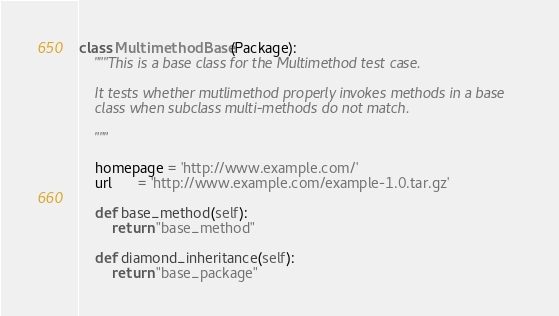<code> <loc_0><loc_0><loc_500><loc_500><_Python_>
class MultimethodBase(Package):
    """This is a base class for the Multimethod test case.

    It tests whether mutlimethod properly invokes methods in a base
    class when subclass multi-methods do not match.

    """

    homepage = 'http://www.example.com/'
    url      = 'http://www.example.com/example-1.0.tar.gz'

    def base_method(self):
        return "base_method"

    def diamond_inheritance(self):
        return "base_package"
</code> 